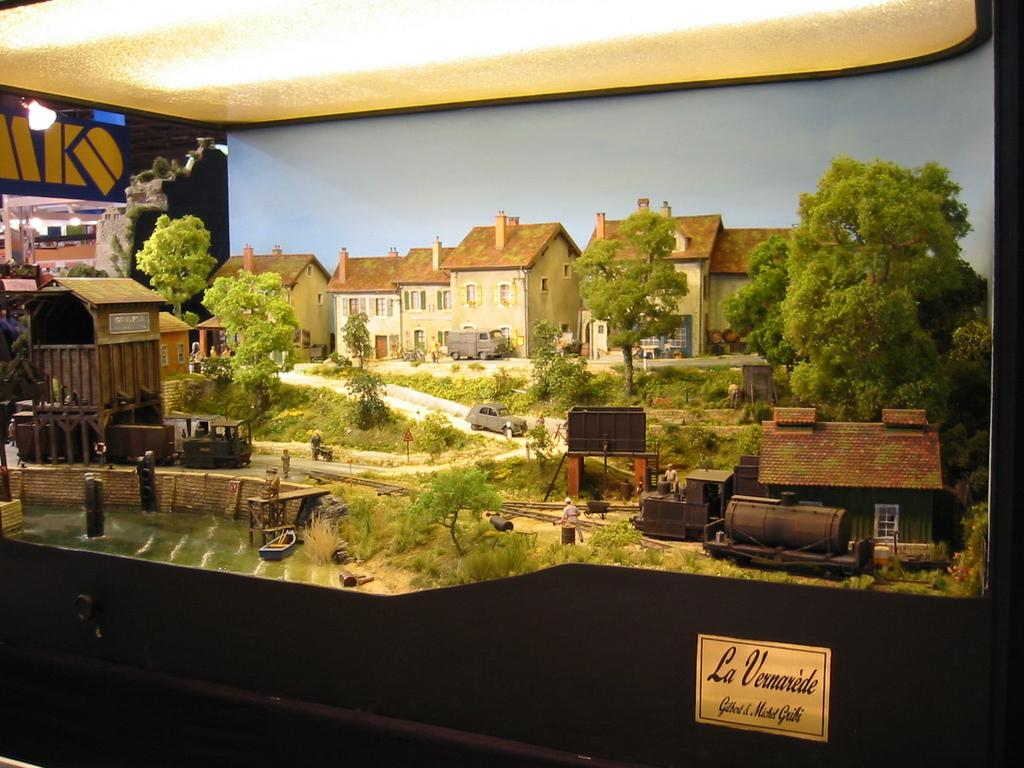<image>
Relay a brief, clear account of the picture shown. A scene of a town is on display and has a placard that reads,"La Vernarede." 